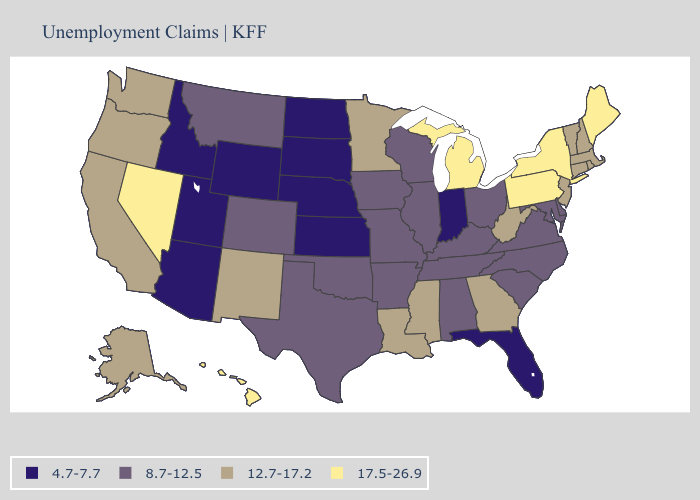Name the states that have a value in the range 12.7-17.2?
Concise answer only. Alaska, California, Connecticut, Georgia, Louisiana, Massachusetts, Minnesota, Mississippi, New Hampshire, New Jersey, New Mexico, Oregon, Rhode Island, Vermont, Washington, West Virginia. What is the highest value in states that border Nebraska?
Answer briefly. 8.7-12.5. Which states have the highest value in the USA?
Concise answer only. Hawaii, Maine, Michigan, Nevada, New York, Pennsylvania. What is the value of Idaho?
Give a very brief answer. 4.7-7.7. Name the states that have a value in the range 4.7-7.7?
Keep it brief. Arizona, Florida, Idaho, Indiana, Kansas, Nebraska, North Dakota, South Dakota, Utah, Wyoming. What is the value of Pennsylvania?
Give a very brief answer. 17.5-26.9. Among the states that border West Virginia , which have the lowest value?
Give a very brief answer. Kentucky, Maryland, Ohio, Virginia. What is the value of Nevada?
Short answer required. 17.5-26.9. Does Vermont have a higher value than Texas?
Give a very brief answer. Yes. What is the highest value in the USA?
Give a very brief answer. 17.5-26.9. What is the value of Mississippi?
Keep it brief. 12.7-17.2. Among the states that border Illinois , which have the highest value?
Be succinct. Iowa, Kentucky, Missouri, Wisconsin. Does Minnesota have a higher value than Alabama?
Give a very brief answer. Yes. Does North Dakota have a higher value than Florida?
Keep it brief. No. 